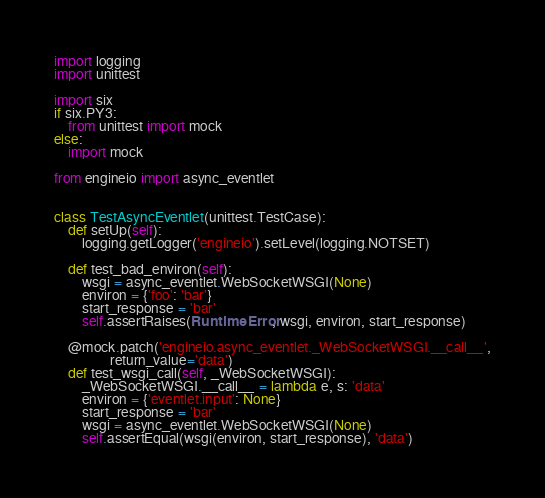Convert code to text. <code><loc_0><loc_0><loc_500><loc_500><_Python_>import logging
import unittest

import six
if six.PY3:
    from unittest import mock
else:
    import mock

from engineio import async_eventlet


class TestAsyncEventlet(unittest.TestCase):
    def setUp(self):
        logging.getLogger('engineio').setLevel(logging.NOTSET)

    def test_bad_environ(self):
        wsgi = async_eventlet.WebSocketWSGI(None)
        environ = {'foo': 'bar'}
        start_response = 'bar'
        self.assertRaises(RuntimeError, wsgi, environ, start_response)

    @mock.patch('engineio.async_eventlet._WebSocketWSGI.__call__',
                return_value='data')
    def test_wsgi_call(self, _WebSocketWSGI):
        _WebSocketWSGI.__call__ = lambda e, s: 'data'
        environ = {'eventlet.input': None}
        start_response = 'bar'
        wsgi = async_eventlet.WebSocketWSGI(None)
        self.assertEqual(wsgi(environ, start_response), 'data')
</code> 